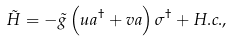Convert formula to latex. <formula><loc_0><loc_0><loc_500><loc_500>\tilde { H } = - \tilde { g } \left ( u a ^ { \dagger } + v a \right ) \sigma ^ { \dagger } + H . c . ,</formula> 